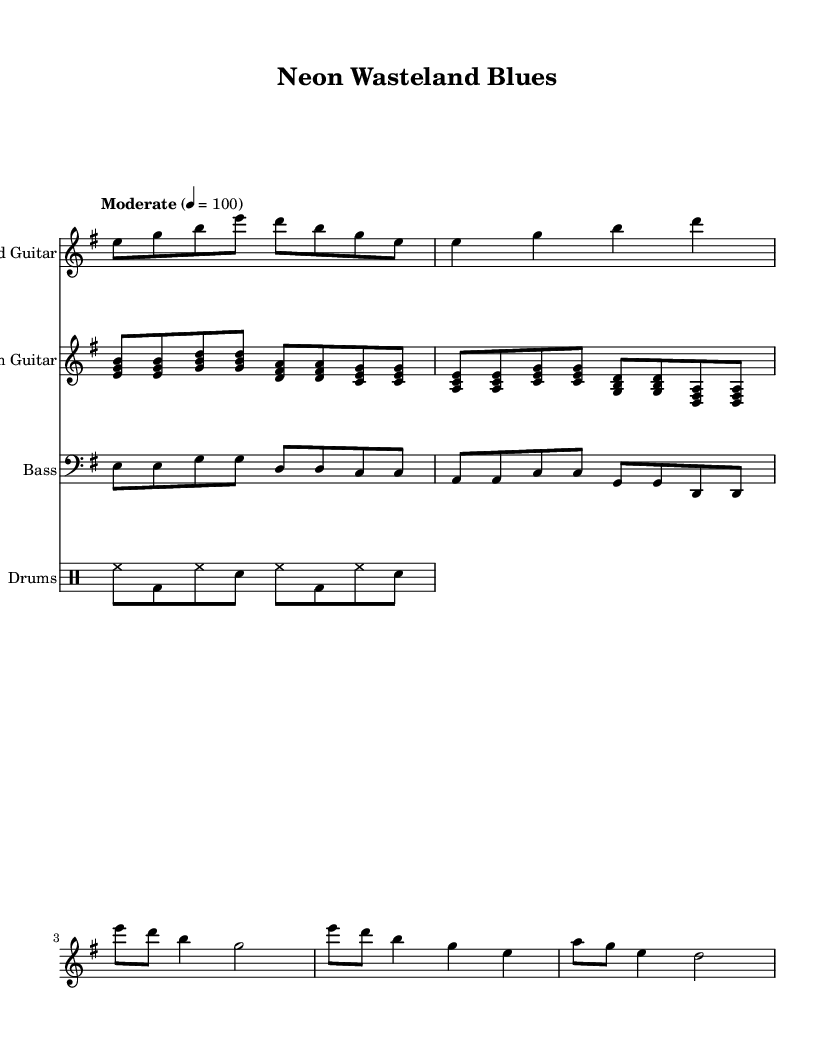What is the key signature of this music? The key signature is E minor, which contains one sharp (F#). This can be determined by looking at the initial part of the sheet music.
Answer: E minor What is the time signature of the piece? The time signature is 4/4, indicated at the beginning of the score. This means there are four beats per measure and the quarter note receives one beat.
Answer: 4/4 What is the tempo marking given in the sheet music? The tempo marking is "Moderate," with a metronome marking of 100 beats per minute. This indicates the desired speed of the music.
Answer: Moderate 100 How many measures are there in the rhythm guitar part? Counting the measures in the rhythm guitar section yields a total of six measures. The measures are clearly marked by vertical lines in the sheet music.
Answer: Six Which instruments are included in this score? The instruments listed in the score are Lead Guitar, Rhythm Guitar, Bass, and Drums. Each instrument has its own staff within the score.
Answer: Lead Guitar, Rhythm Guitar, Bass, Drums What is the chord progression used in the chorus? The chorus features a typical progression that includes the chords A, C, G, and D. This can be deduced from the notated notes in the rhythm guitar part during the chorus section.
Answer: A, C, G, D Is this piece written for a solo performer or a band? The piece is written for a band as it features multiple instrumental parts including guitars, bass, and drums. This is indicated by the presence of separate staves for each instrument in the score.
Answer: Band 